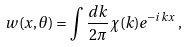<formula> <loc_0><loc_0><loc_500><loc_500>w ( x , \theta ) = \int \frac { d k } { 2 \pi } \chi ( k ) e ^ { - i k x } \, ,</formula> 